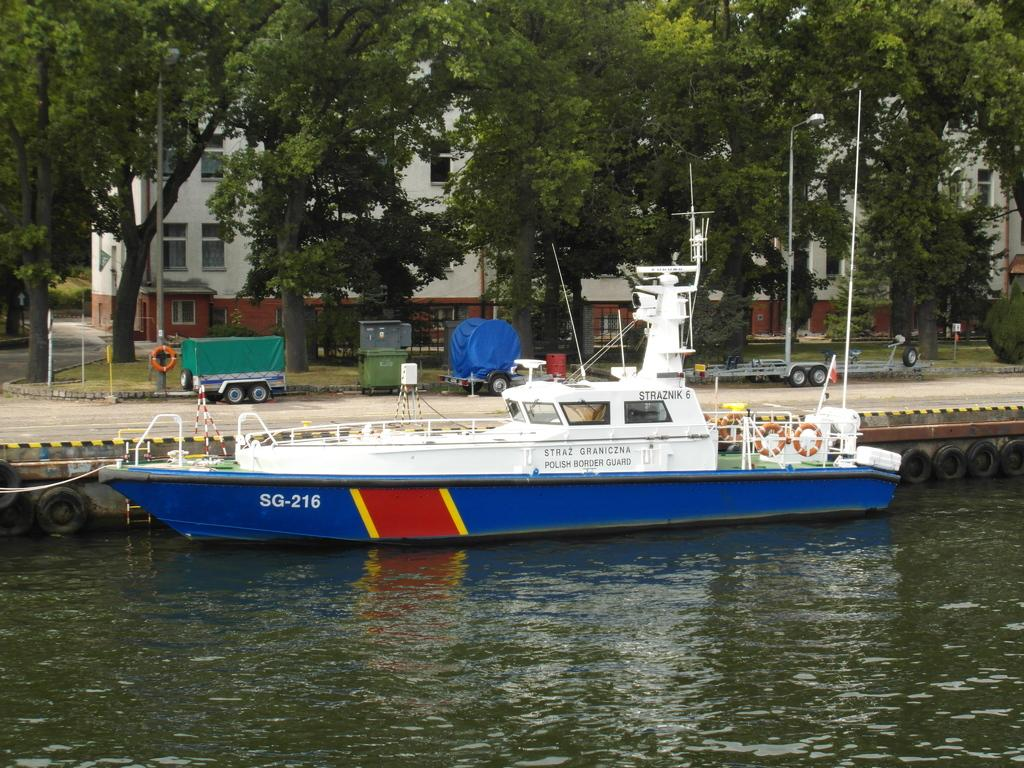What is in the water in the image? There is a boat in the water in the image. What type of vegetation can be seen in the image? There are trees visible in the image. What type of transportation is present in the image? There are carts in the image. What can be seen in the background of the image? There are buildings in the background of the image. What type of lighting is present in the image? There are pole lights in the image. What type of loaf is being used as a chess piece in the image? There is no loaf or chess set present in the image. What type of wool is being used to create the boat in the image? The boat in the image is not made of wool; it is likely made of a more durable material like wood or metal. 